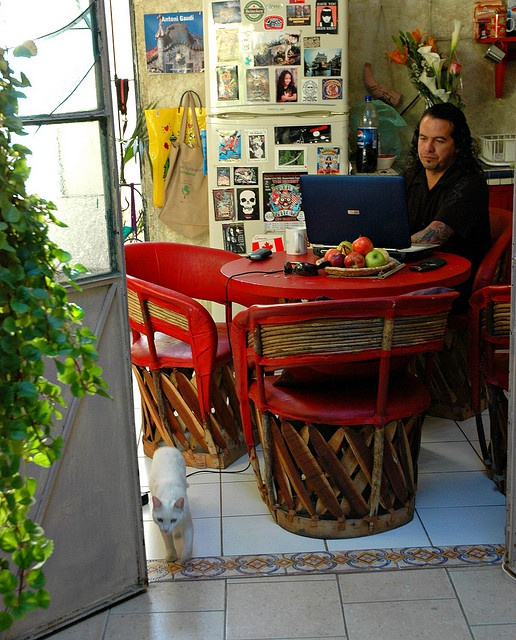Describe the objects in this image and their specific colors. I can see chair in white, black, maroon, and olive tones, refrigerator in white, beige, tan, and black tones, chair in white, black, maroon, and brown tones, people in white, black, maroon, brown, and salmon tones, and dining table in white, maroon, black, and brown tones in this image. 